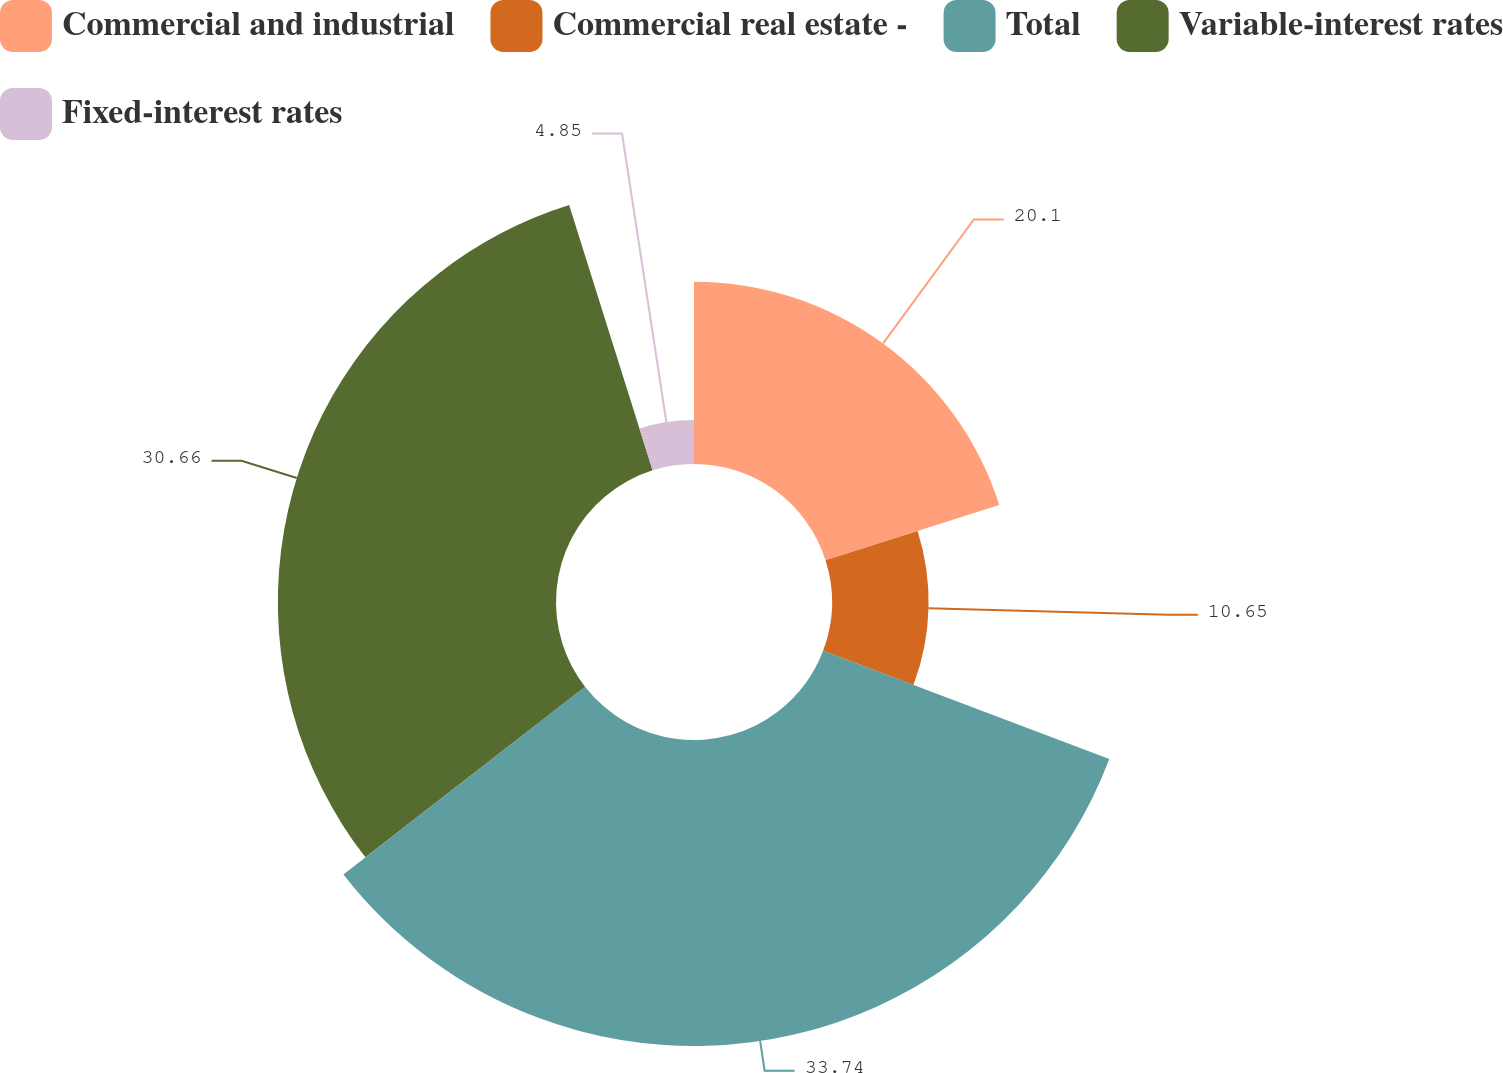Convert chart to OTSL. <chart><loc_0><loc_0><loc_500><loc_500><pie_chart><fcel>Commercial and industrial<fcel>Commercial real estate -<fcel>Total<fcel>Variable-interest rates<fcel>Fixed-interest rates<nl><fcel>20.1%<fcel>10.65%<fcel>33.73%<fcel>30.66%<fcel>4.85%<nl></chart> 